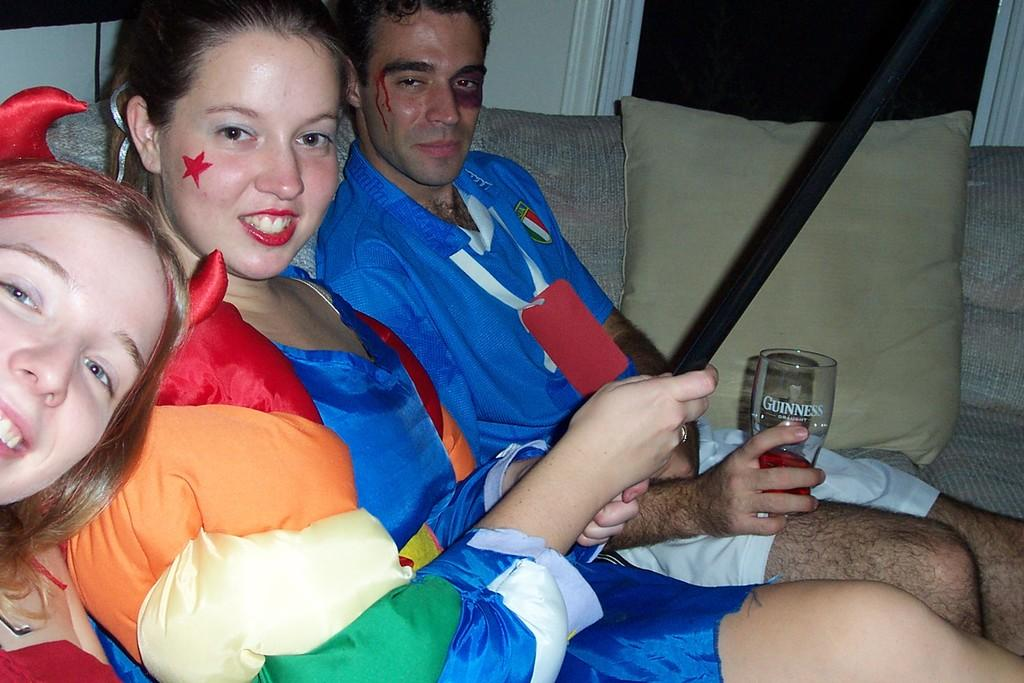<image>
Share a concise interpretation of the image provided. a man and two women sitting on a sofa with the man holding a nearly empty "Guinness" glass 